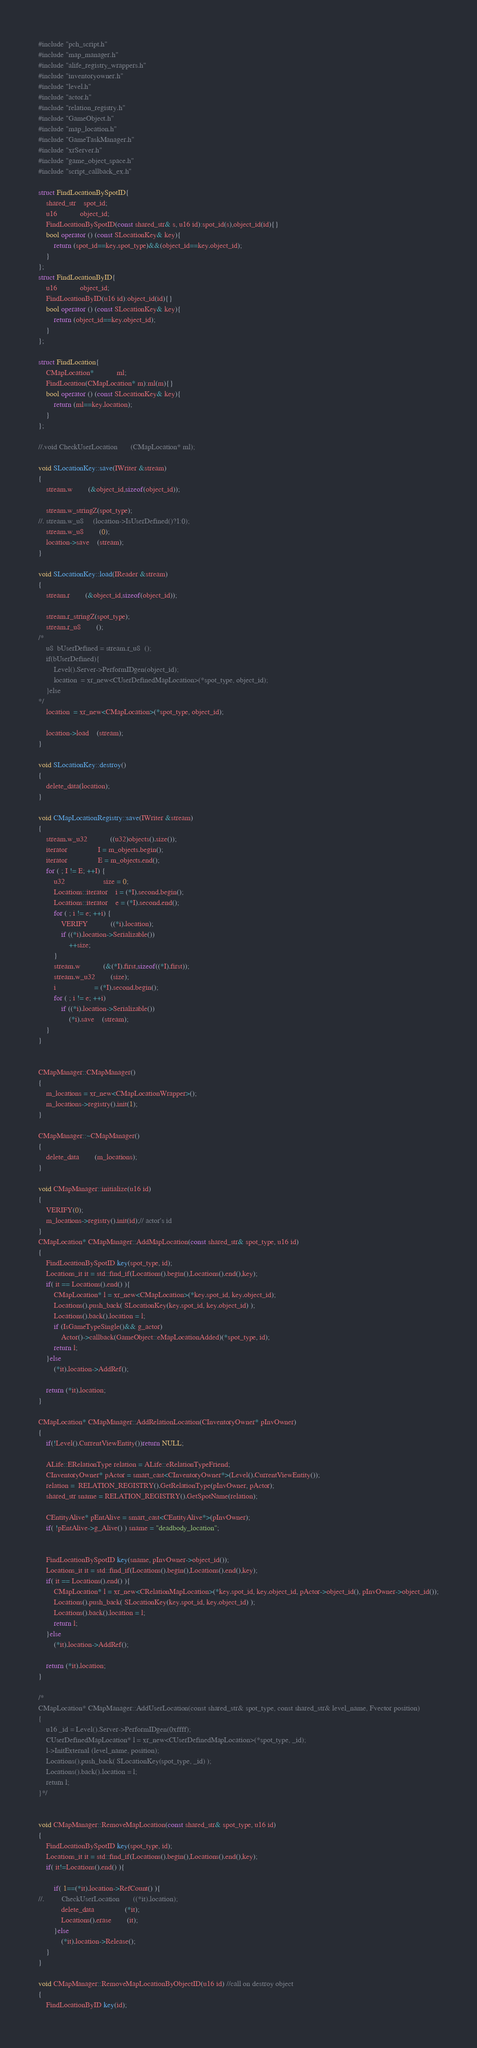Convert code to text. <code><loc_0><loc_0><loc_500><loc_500><_C++_>#include "pch_script.h"
#include "map_manager.h"
#include "alife_registry_wrappers.h"
#include "inventoryowner.h"
#include "level.h"
#include "actor.h"
#include "relation_registry.h"
#include "GameObject.h"
#include "map_location.h"
#include "GameTaskManager.h"
#include "xrServer.h"
#include "game_object_space.h"
#include "script_callback_ex.h"

struct FindLocationBySpotID{
	shared_str	spot_id;
	u16			object_id;
	FindLocationBySpotID(const shared_str& s, u16 id):spot_id(s),object_id(id){}
	bool operator () (const SLocationKey& key){
		return (spot_id==key.spot_type)&&(object_id==key.object_id);
	}
};
struct FindLocationByID{
	u16			object_id;
	FindLocationByID(u16 id):object_id(id){}
	bool operator () (const SLocationKey& key){
		return (object_id==key.object_id);
	}
};

struct FindLocation{
	CMapLocation*			ml;
	FindLocation(CMapLocation* m):ml(m){}
	bool operator () (const SLocationKey& key){
		return (ml==key.location);
	}
};

//.void CheckUserLocation		(CMapLocation* ml);

void SLocationKey::save(IWriter &stream)
{
	stream.w		(&object_id,sizeof(object_id));

	stream.w_stringZ(spot_type);
//.	stream.w_u8		(location->IsUserDefined()?1:0);
	stream.w_u8		(0);
	location->save	(stream);
}
	
void SLocationKey::load(IReader &stream)
{
	stream.r		(&object_id,sizeof(object_id));

	stream.r_stringZ(spot_type);
	stream.r_u8		();
/*
	u8	bUserDefined = stream.r_u8	();
	if(bUserDefined){
		Level().Server->PerformIDgen(object_id);
		location  = xr_new<CUserDefinedMapLocation>(*spot_type, object_id);
	}else
*/
	location  = xr_new<CMapLocation>(*spot_type, object_id);

	location->load	(stream);
}

void SLocationKey::destroy()
{
	delete_data(location);
}

void CMapLocationRegistry::save(IWriter &stream)
{
	stream.w_u32			((u32)objects().size());
	iterator				I = m_objects.begin();
	iterator				E = m_objects.end();
	for ( ; I != E; ++I) {
		u32					size = 0;
		Locations::iterator	i = (*I).second.begin();
		Locations::iterator	e = (*I).second.end();
		for ( ; i != e; ++i) {
			VERIFY			((*i).location);
			if ((*i).location->Serializable())
				++size;
		}
		stream.w			(&(*I).first,sizeof((*I).first));
		stream.w_u32		(size);
		i					= (*I).second.begin();
		for ( ; i != e; ++i)
			if ((*i).location->Serializable())
				(*i).save	(stream);
	}
}


CMapManager::CMapManager()
{
	m_locations = xr_new<CMapLocationWrapper>();
	m_locations->registry().init(1);
}

CMapManager::~CMapManager()
{
	delete_data		(m_locations);
}

void CMapManager::initialize(u16 id)
{
	VERIFY(0);
	m_locations->registry().init(id);// actor's id
}
CMapLocation* CMapManager::AddMapLocation(const shared_str& spot_type, u16 id)
{
	FindLocationBySpotID key(spot_type, id);
	Locations_it it = std::find_if(Locations().begin(),Locations().end(),key);
	if( it == Locations().end() ){
		CMapLocation* l = xr_new<CMapLocation>(*key.spot_id, key.object_id);
		Locations().push_back( SLocationKey(key.spot_id, key.object_id) );
		Locations().back().location = l;
		if (IsGameTypeSingle()&& g_actor)
			Actor()->callback(GameObject::eMapLocationAdded)(*spot_type, id);
		return l;
	}else
		(*it).location->AddRef();

	return (*it).location;
}

CMapLocation* CMapManager::AddRelationLocation(CInventoryOwner* pInvOwner)
{
	if(!Level().CurrentViewEntity())return NULL;

	ALife::ERelationType relation = ALife::eRelationTypeFriend;
	CInventoryOwner* pActor = smart_cast<CInventoryOwner*>(Level().CurrentViewEntity());
	relation =  RELATION_REGISTRY().GetRelationType(pInvOwner, pActor);
	shared_str sname = RELATION_REGISTRY().GetSpotName(relation);

	CEntityAlive* pEntAlive = smart_cast<CEntityAlive*>(pInvOwner);
	if( !pEntAlive->g_Alive() ) sname = "deadbody_location";


	FindLocationBySpotID key(sname, pInvOwner->object_id());
	Locations_it it = std::find_if(Locations().begin(),Locations().end(),key);
	if( it == Locations().end() ){
		CMapLocation* l = xr_new<CRelationMapLocation>(*key.spot_id, key.object_id, pActor->object_id(), pInvOwner->object_id());
		Locations().push_back( SLocationKey(key.spot_id, key.object_id) );
		Locations().back().location = l;
		return l;
	}else
		(*it).location->AddRef();

	return (*it).location;
}

/*	
CMapLocation* CMapManager::AddUserLocation(const shared_str& spot_type, const shared_str& level_name, Fvector position)
{
	u16 _id	= Level().Server->PerformIDgen(0xffff);
	CUserDefinedMapLocation* l = xr_new<CUserDefinedMapLocation>(*spot_type, _id);
	l->InitExternal	(level_name, position);
	Locations().push_back( SLocationKey(spot_type, _id) );
	Locations().back().location = l;
	return l;
}*/


void CMapManager::RemoveMapLocation(const shared_str& spot_type, u16 id)
{
	FindLocationBySpotID key(spot_type, id);
	Locations_it it = std::find_if(Locations().begin(),Locations().end(),key);
	if( it!=Locations().end() ){

		if( 1==(*it).location->RefCount() ){
//.			CheckUserLocation		((*it).location);
			delete_data				(*it);
			Locations().erase		(it);
		}else
			(*it).location->Release();
	}
}

void CMapManager::RemoveMapLocationByObjectID(u16 id) //call on destroy object
{
	FindLocationByID key(id);</code> 